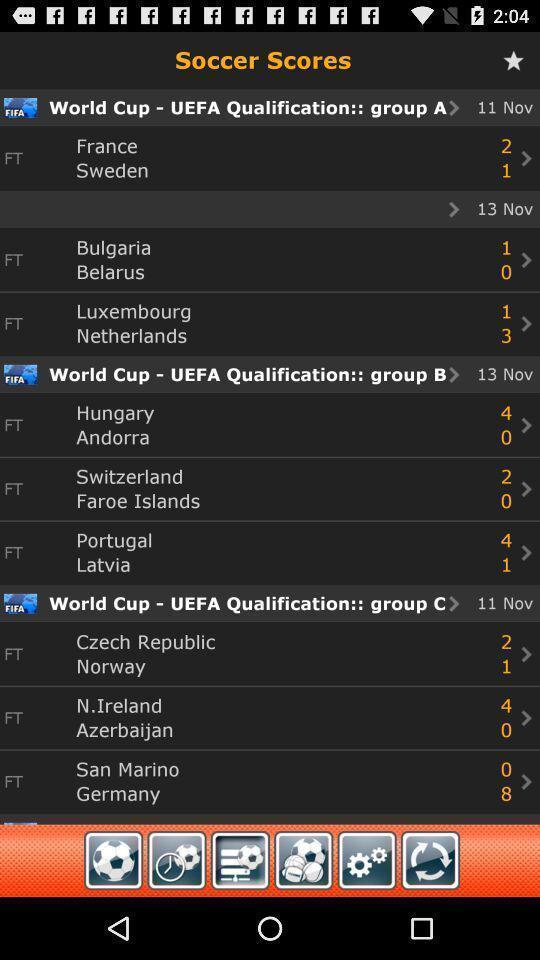What details can you identify in this image? Window displaying livescore of sports. 